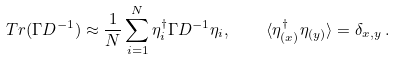<formula> <loc_0><loc_0><loc_500><loc_500>T r ( \Gamma D ^ { - 1 } ) \approx \frac { 1 } { N } \sum _ { i = 1 } ^ { N } \eta _ { i } ^ { \dagger } \Gamma D ^ { - 1 } \eta _ { i } , \quad \langle \eta _ { ( x ) } ^ { \dagger } \eta _ { ( y ) } \rangle = \delta _ { x , y } \, .</formula> 